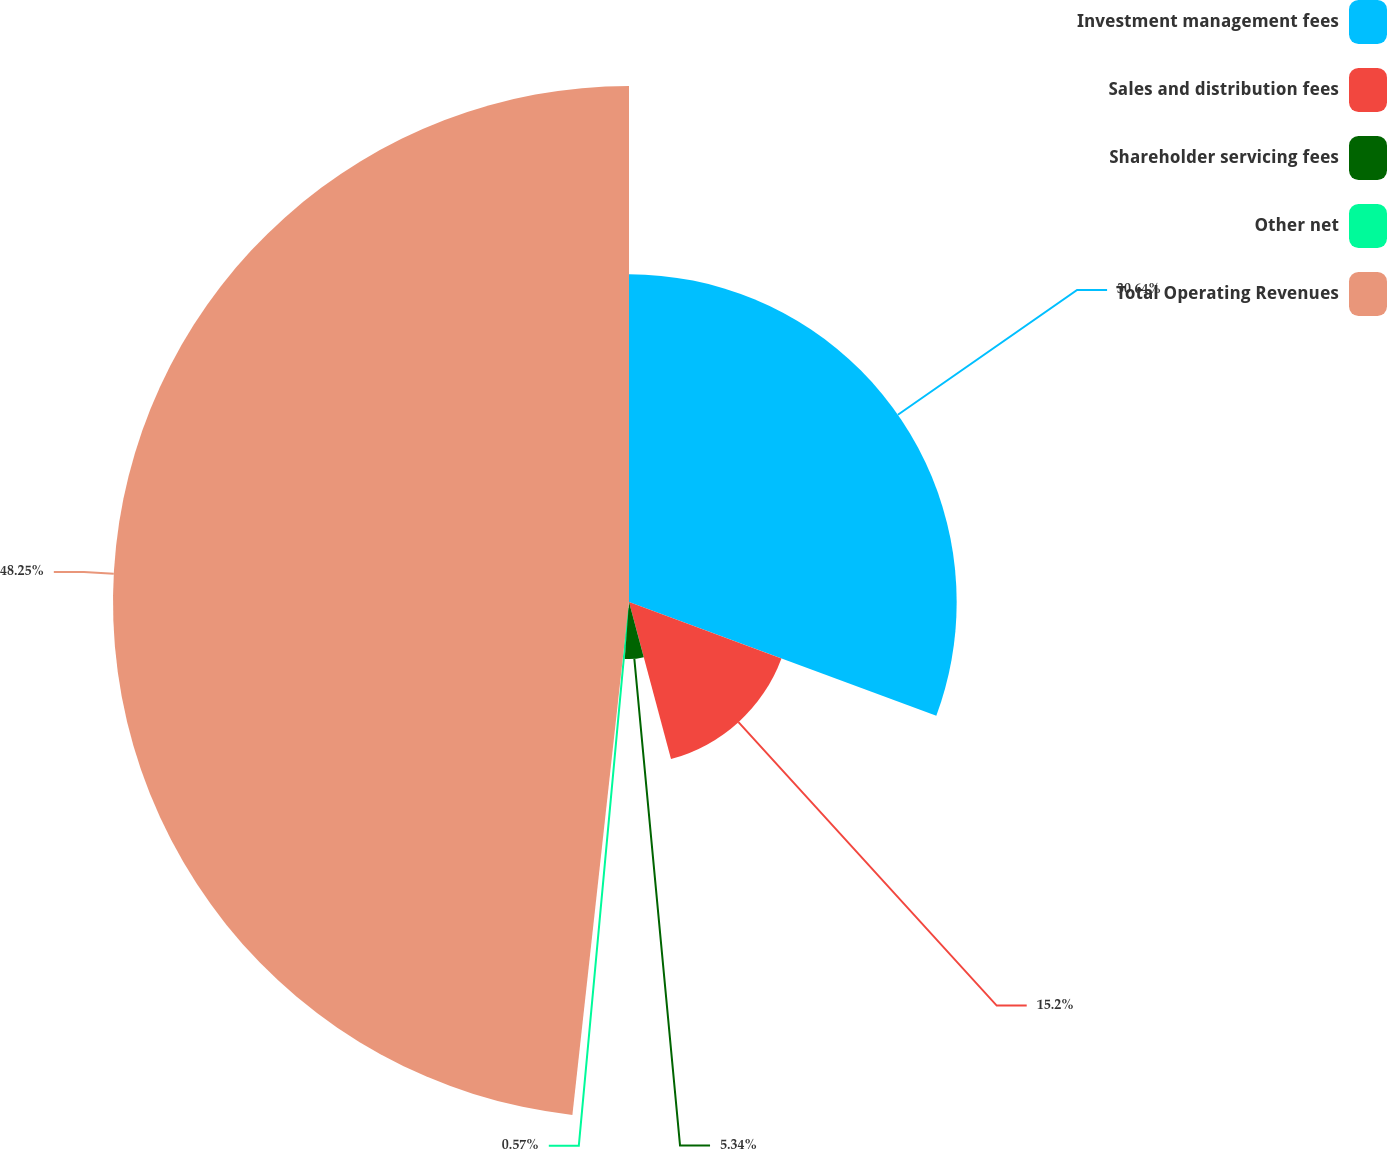Convert chart. <chart><loc_0><loc_0><loc_500><loc_500><pie_chart><fcel>Investment management fees<fcel>Sales and distribution fees<fcel>Shareholder servicing fees<fcel>Other net<fcel>Total Operating Revenues<nl><fcel>30.64%<fcel>15.2%<fcel>5.34%<fcel>0.57%<fcel>48.25%<nl></chart> 